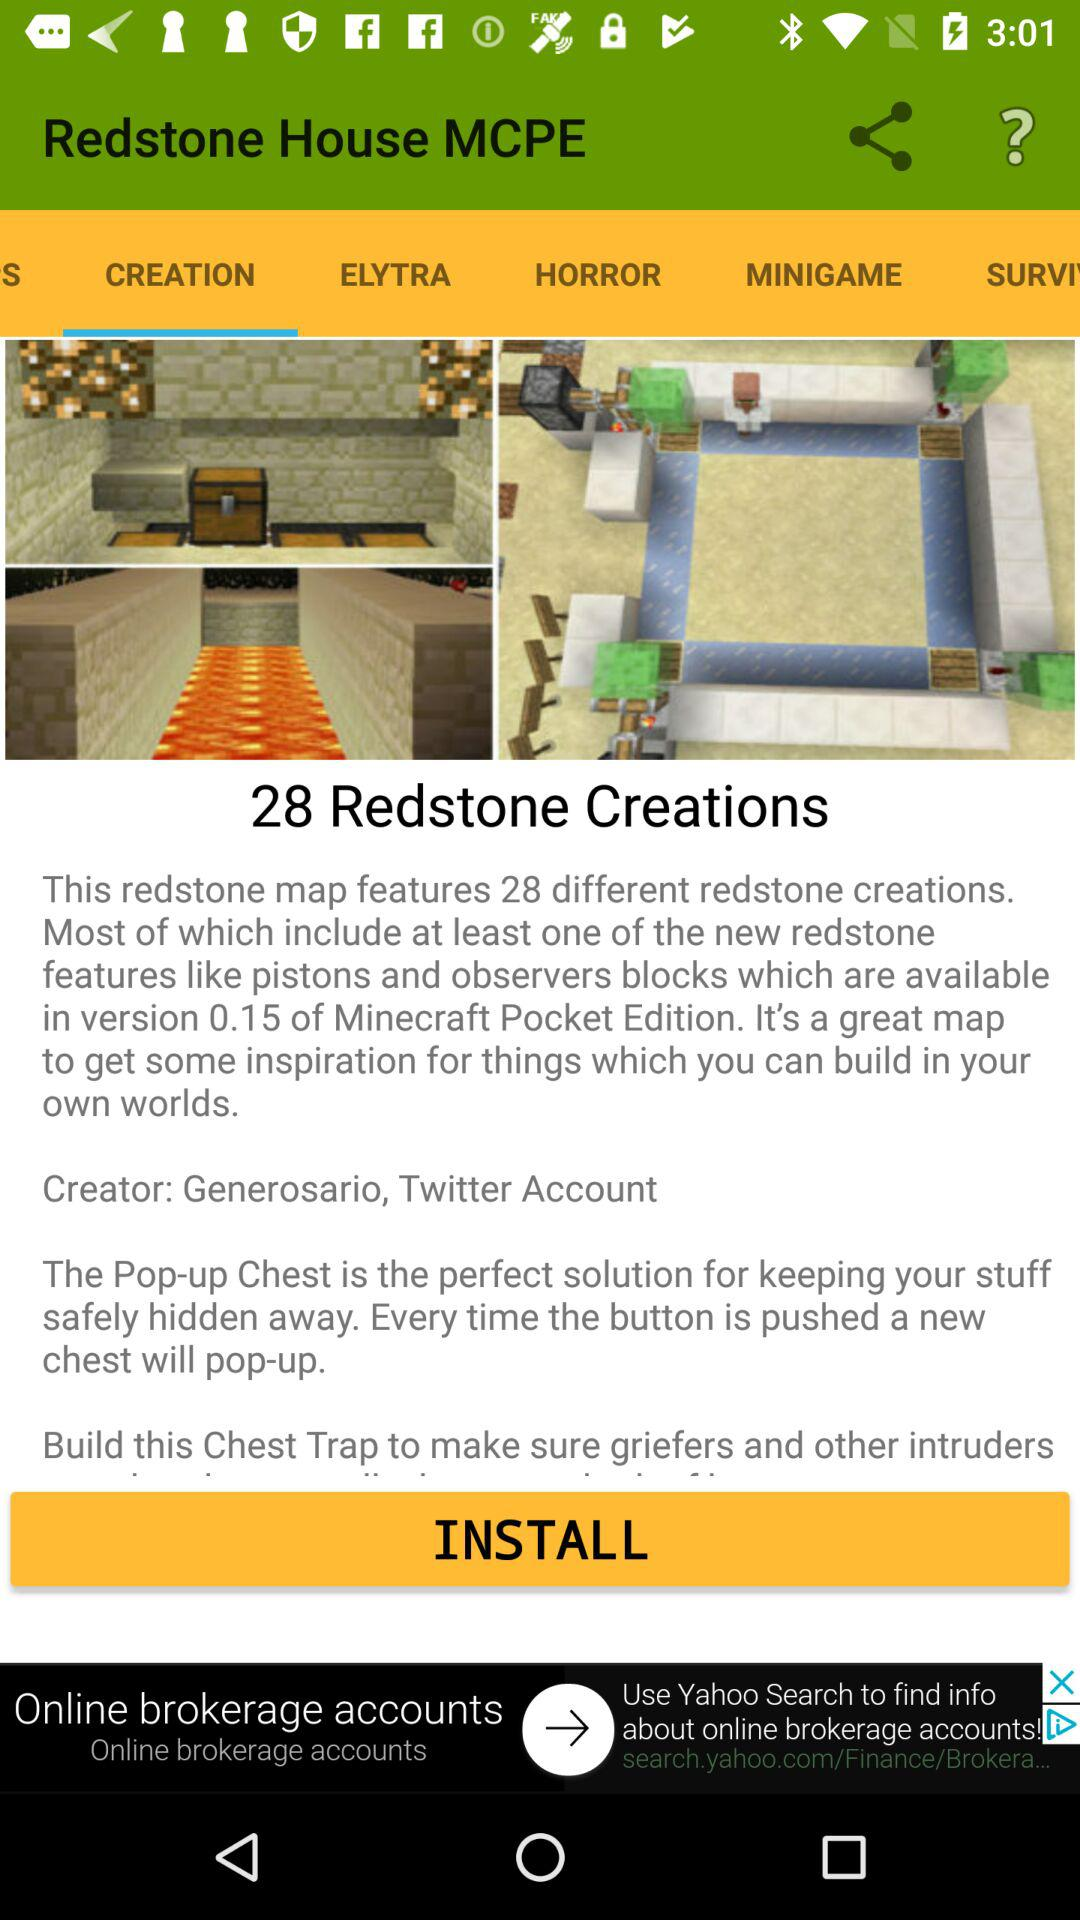What tab is selected in Redstone House MCPE? The selected tab is "CREATION". 